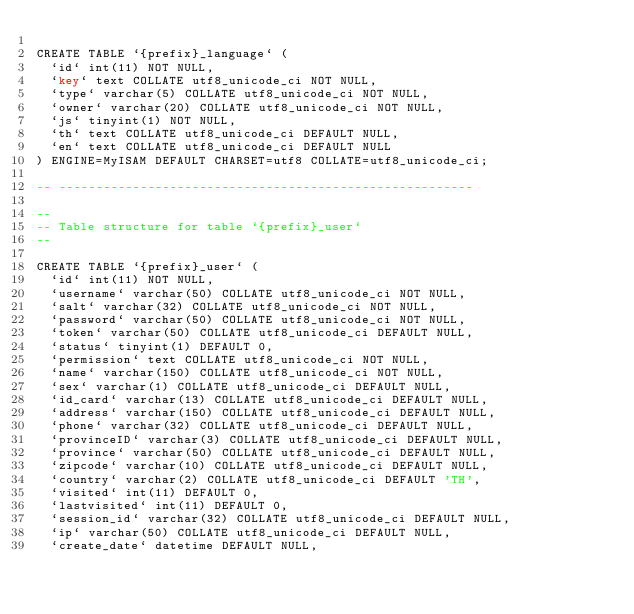Convert code to text. <code><loc_0><loc_0><loc_500><loc_500><_SQL_>
CREATE TABLE `{prefix}_language` (
  `id` int(11) NOT NULL,
  `key` text COLLATE utf8_unicode_ci NOT NULL,
  `type` varchar(5) COLLATE utf8_unicode_ci NOT NULL,
  `owner` varchar(20) COLLATE utf8_unicode_ci NOT NULL,
  `js` tinyint(1) NOT NULL,
  `th` text COLLATE utf8_unicode_ci DEFAULT NULL,
  `en` text COLLATE utf8_unicode_ci DEFAULT NULL
) ENGINE=MyISAM DEFAULT CHARSET=utf8 COLLATE=utf8_unicode_ci;

-- --------------------------------------------------------

--
-- Table structure for table `{prefix}_user`
--

CREATE TABLE `{prefix}_user` (
  `id` int(11) NOT NULL,
  `username` varchar(50) COLLATE utf8_unicode_ci NOT NULL,
  `salt` varchar(32) COLLATE utf8_unicode_ci NOT NULL,
  `password` varchar(50) COLLATE utf8_unicode_ci NOT NULL,
  `token` varchar(50) COLLATE utf8_unicode_ci DEFAULT NULL,
  `status` tinyint(1) DEFAULT 0,
  `permission` text COLLATE utf8_unicode_ci NOT NULL,
  `name` varchar(150) COLLATE utf8_unicode_ci NOT NULL,
  `sex` varchar(1) COLLATE utf8_unicode_ci DEFAULT NULL,
  `id_card` varchar(13) COLLATE utf8_unicode_ci DEFAULT NULL,
  `address` varchar(150) COLLATE utf8_unicode_ci DEFAULT NULL,
  `phone` varchar(32) COLLATE utf8_unicode_ci DEFAULT NULL,
  `provinceID` varchar(3) COLLATE utf8_unicode_ci DEFAULT NULL,
  `province` varchar(50) COLLATE utf8_unicode_ci DEFAULT NULL,
  `zipcode` varchar(10) COLLATE utf8_unicode_ci DEFAULT NULL,
  `country` varchar(2) COLLATE utf8_unicode_ci DEFAULT 'TH',
  `visited` int(11) DEFAULT 0,
  `lastvisited` int(11) DEFAULT 0,
  `session_id` varchar(32) COLLATE utf8_unicode_ci DEFAULT NULL,
  `ip` varchar(50) COLLATE utf8_unicode_ci DEFAULT NULL,
  `create_date` datetime DEFAULT NULL,</code> 